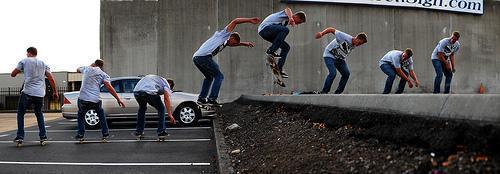How many cars are in the picture?
Give a very brief answer. 1. 